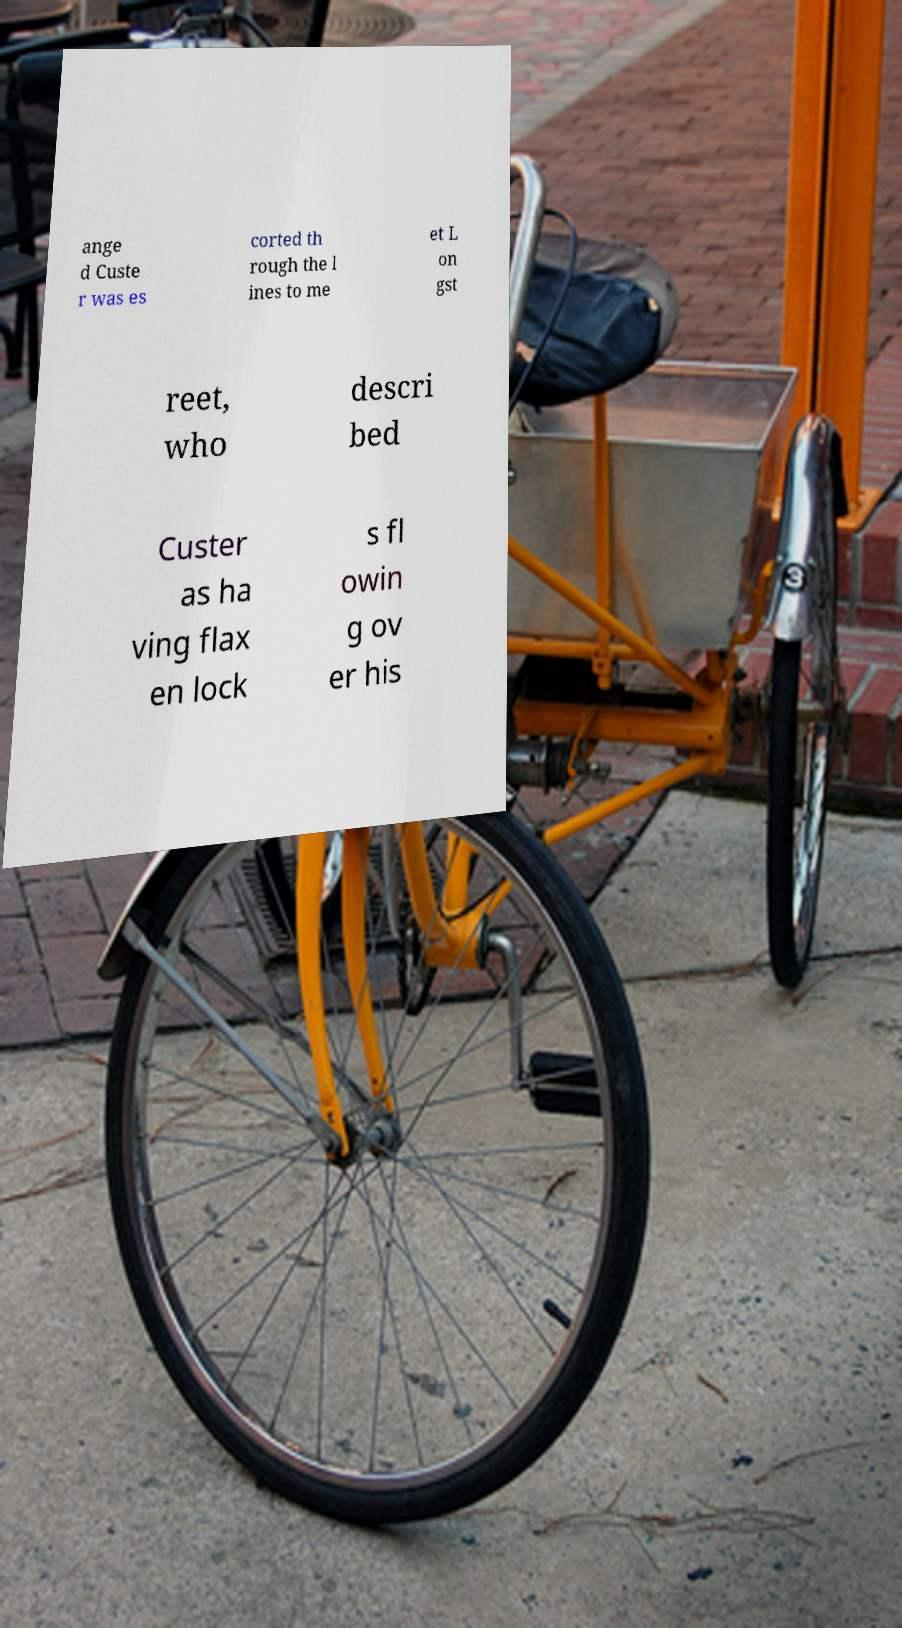There's text embedded in this image that I need extracted. Can you transcribe it verbatim? ange d Custe r was es corted th rough the l ines to me et L on gst reet, who descri bed Custer as ha ving flax en lock s fl owin g ov er his 